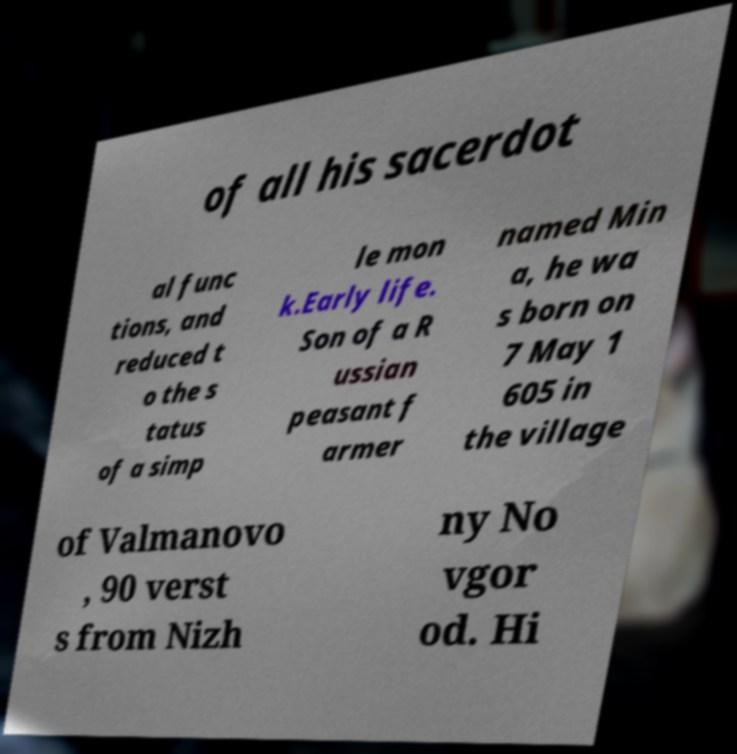Could you extract and type out the text from this image? of all his sacerdot al func tions, and reduced t o the s tatus of a simp le mon k.Early life. Son of a R ussian peasant f armer named Min a, he wa s born on 7 May 1 605 in the village of Valmanovo , 90 verst s from Nizh ny No vgor od. Hi 